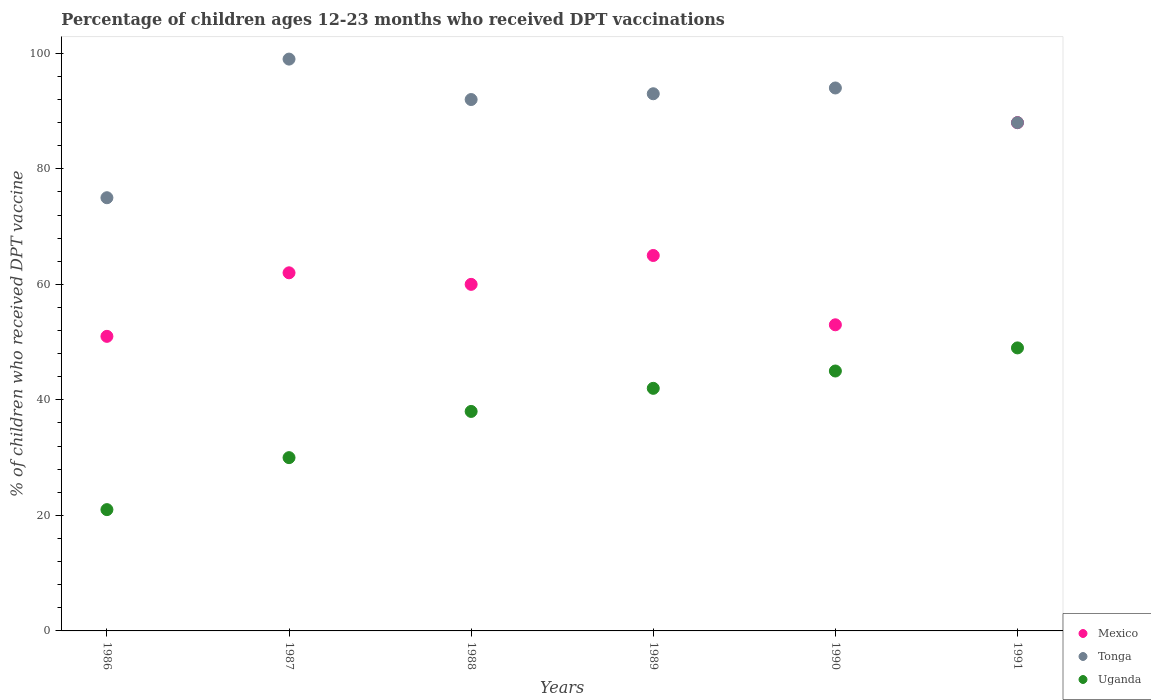Across all years, what is the maximum percentage of children who received DPT vaccination in Tonga?
Ensure brevity in your answer.  99. Across all years, what is the minimum percentage of children who received DPT vaccination in Mexico?
Provide a short and direct response. 51. In which year was the percentage of children who received DPT vaccination in Uganda maximum?
Provide a short and direct response. 1991. In which year was the percentage of children who received DPT vaccination in Uganda minimum?
Provide a short and direct response. 1986. What is the total percentage of children who received DPT vaccination in Mexico in the graph?
Ensure brevity in your answer.  379. What is the difference between the percentage of children who received DPT vaccination in Mexico in 1987 and that in 1989?
Provide a short and direct response. -3. What is the average percentage of children who received DPT vaccination in Mexico per year?
Your answer should be very brief. 63.17. In the year 1991, what is the difference between the percentage of children who received DPT vaccination in Tonga and percentage of children who received DPT vaccination in Uganda?
Ensure brevity in your answer.  39. What is the ratio of the percentage of children who received DPT vaccination in Mexico in 1986 to that in 1987?
Provide a succinct answer. 0.82. Is the difference between the percentage of children who received DPT vaccination in Tonga in 1989 and 1990 greater than the difference between the percentage of children who received DPT vaccination in Uganda in 1989 and 1990?
Offer a terse response. Yes. What is the difference between the highest and the second highest percentage of children who received DPT vaccination in Tonga?
Keep it short and to the point. 5. In how many years, is the percentage of children who received DPT vaccination in Tonga greater than the average percentage of children who received DPT vaccination in Tonga taken over all years?
Your answer should be compact. 4. Is the sum of the percentage of children who received DPT vaccination in Mexico in 1987 and 1991 greater than the maximum percentage of children who received DPT vaccination in Uganda across all years?
Give a very brief answer. Yes. Is it the case that in every year, the sum of the percentage of children who received DPT vaccination in Uganda and percentage of children who received DPT vaccination in Tonga  is greater than the percentage of children who received DPT vaccination in Mexico?
Your answer should be compact. Yes. Does the percentage of children who received DPT vaccination in Tonga monotonically increase over the years?
Ensure brevity in your answer.  No. Is the percentage of children who received DPT vaccination in Mexico strictly less than the percentage of children who received DPT vaccination in Uganda over the years?
Make the answer very short. No. How many dotlines are there?
Provide a succinct answer. 3. How many years are there in the graph?
Your response must be concise. 6. What is the difference between two consecutive major ticks on the Y-axis?
Offer a terse response. 20. Are the values on the major ticks of Y-axis written in scientific E-notation?
Offer a very short reply. No. Does the graph contain any zero values?
Give a very brief answer. No. Does the graph contain grids?
Offer a very short reply. No. Where does the legend appear in the graph?
Keep it short and to the point. Bottom right. How many legend labels are there?
Give a very brief answer. 3. How are the legend labels stacked?
Make the answer very short. Vertical. What is the title of the graph?
Offer a terse response. Percentage of children ages 12-23 months who received DPT vaccinations. Does "Togo" appear as one of the legend labels in the graph?
Your response must be concise. No. What is the label or title of the Y-axis?
Ensure brevity in your answer.  % of children who received DPT vaccine. What is the % of children who received DPT vaccine of Tonga in 1986?
Keep it short and to the point. 75. What is the % of children who received DPT vaccine of Uganda in 1986?
Offer a very short reply. 21. What is the % of children who received DPT vaccine in Mexico in 1988?
Provide a succinct answer. 60. What is the % of children who received DPT vaccine in Tonga in 1988?
Your response must be concise. 92. What is the % of children who received DPT vaccine of Mexico in 1989?
Your answer should be very brief. 65. What is the % of children who received DPT vaccine of Tonga in 1989?
Give a very brief answer. 93. What is the % of children who received DPT vaccine in Uganda in 1989?
Provide a succinct answer. 42. What is the % of children who received DPT vaccine of Tonga in 1990?
Offer a very short reply. 94. What is the % of children who received DPT vaccine of Uganda in 1990?
Your response must be concise. 45. What is the % of children who received DPT vaccine in Mexico in 1991?
Provide a succinct answer. 88. What is the % of children who received DPT vaccine of Tonga in 1991?
Provide a succinct answer. 88. Across all years, what is the maximum % of children who received DPT vaccine in Mexico?
Provide a short and direct response. 88. Across all years, what is the maximum % of children who received DPT vaccine of Tonga?
Keep it short and to the point. 99. Across all years, what is the maximum % of children who received DPT vaccine in Uganda?
Provide a succinct answer. 49. Across all years, what is the minimum % of children who received DPT vaccine of Mexico?
Give a very brief answer. 51. What is the total % of children who received DPT vaccine in Mexico in the graph?
Provide a short and direct response. 379. What is the total % of children who received DPT vaccine of Tonga in the graph?
Your response must be concise. 541. What is the total % of children who received DPT vaccine in Uganda in the graph?
Your answer should be compact. 225. What is the difference between the % of children who received DPT vaccine of Mexico in 1986 and that in 1987?
Ensure brevity in your answer.  -11. What is the difference between the % of children who received DPT vaccine of Uganda in 1986 and that in 1987?
Ensure brevity in your answer.  -9. What is the difference between the % of children who received DPT vaccine in Mexico in 1986 and that in 1989?
Your response must be concise. -14. What is the difference between the % of children who received DPT vaccine in Tonga in 1986 and that in 1989?
Offer a very short reply. -18. What is the difference between the % of children who received DPT vaccine in Mexico in 1986 and that in 1991?
Offer a terse response. -37. What is the difference between the % of children who received DPT vaccine in Mexico in 1987 and that in 1988?
Your answer should be compact. 2. What is the difference between the % of children who received DPT vaccine in Mexico in 1987 and that in 1989?
Keep it short and to the point. -3. What is the difference between the % of children who received DPT vaccine of Tonga in 1987 and that in 1989?
Keep it short and to the point. 6. What is the difference between the % of children who received DPT vaccine of Tonga in 1987 and that in 1990?
Keep it short and to the point. 5. What is the difference between the % of children who received DPT vaccine in Mexico in 1988 and that in 1990?
Provide a succinct answer. 7. What is the difference between the % of children who received DPT vaccine in Uganda in 1988 and that in 1990?
Offer a terse response. -7. What is the difference between the % of children who received DPT vaccine of Mexico in 1988 and that in 1991?
Offer a very short reply. -28. What is the difference between the % of children who received DPT vaccine in Tonga in 1988 and that in 1991?
Your response must be concise. 4. What is the difference between the % of children who received DPT vaccine in Uganda in 1988 and that in 1991?
Offer a terse response. -11. What is the difference between the % of children who received DPT vaccine in Mexico in 1989 and that in 1990?
Your answer should be compact. 12. What is the difference between the % of children who received DPT vaccine in Tonga in 1989 and that in 1990?
Your answer should be compact. -1. What is the difference between the % of children who received DPT vaccine of Uganda in 1989 and that in 1991?
Make the answer very short. -7. What is the difference between the % of children who received DPT vaccine in Mexico in 1990 and that in 1991?
Offer a terse response. -35. What is the difference between the % of children who received DPT vaccine of Uganda in 1990 and that in 1991?
Your answer should be compact. -4. What is the difference between the % of children who received DPT vaccine of Mexico in 1986 and the % of children who received DPT vaccine of Tonga in 1987?
Provide a short and direct response. -48. What is the difference between the % of children who received DPT vaccine of Mexico in 1986 and the % of children who received DPT vaccine of Tonga in 1988?
Provide a short and direct response. -41. What is the difference between the % of children who received DPT vaccine in Mexico in 1986 and the % of children who received DPT vaccine in Tonga in 1989?
Offer a very short reply. -42. What is the difference between the % of children who received DPT vaccine of Mexico in 1986 and the % of children who received DPT vaccine of Uganda in 1989?
Your answer should be very brief. 9. What is the difference between the % of children who received DPT vaccine in Mexico in 1986 and the % of children who received DPT vaccine in Tonga in 1990?
Provide a short and direct response. -43. What is the difference between the % of children who received DPT vaccine in Mexico in 1986 and the % of children who received DPT vaccine in Uganda in 1990?
Offer a terse response. 6. What is the difference between the % of children who received DPT vaccine of Tonga in 1986 and the % of children who received DPT vaccine of Uganda in 1990?
Ensure brevity in your answer.  30. What is the difference between the % of children who received DPT vaccine of Mexico in 1986 and the % of children who received DPT vaccine of Tonga in 1991?
Offer a very short reply. -37. What is the difference between the % of children who received DPT vaccine in Mexico in 1986 and the % of children who received DPT vaccine in Uganda in 1991?
Give a very brief answer. 2. What is the difference between the % of children who received DPT vaccine in Tonga in 1986 and the % of children who received DPT vaccine in Uganda in 1991?
Provide a short and direct response. 26. What is the difference between the % of children who received DPT vaccine of Mexico in 1987 and the % of children who received DPT vaccine of Tonga in 1989?
Ensure brevity in your answer.  -31. What is the difference between the % of children who received DPT vaccine in Mexico in 1987 and the % of children who received DPT vaccine in Uganda in 1989?
Keep it short and to the point. 20. What is the difference between the % of children who received DPT vaccine of Tonga in 1987 and the % of children who received DPT vaccine of Uganda in 1989?
Provide a succinct answer. 57. What is the difference between the % of children who received DPT vaccine of Mexico in 1987 and the % of children who received DPT vaccine of Tonga in 1990?
Keep it short and to the point. -32. What is the difference between the % of children who received DPT vaccine of Mexico in 1987 and the % of children who received DPT vaccine of Uganda in 1990?
Your response must be concise. 17. What is the difference between the % of children who received DPT vaccine of Tonga in 1987 and the % of children who received DPT vaccine of Uganda in 1990?
Provide a short and direct response. 54. What is the difference between the % of children who received DPT vaccine in Tonga in 1987 and the % of children who received DPT vaccine in Uganda in 1991?
Make the answer very short. 50. What is the difference between the % of children who received DPT vaccine of Mexico in 1988 and the % of children who received DPT vaccine of Tonga in 1989?
Offer a terse response. -33. What is the difference between the % of children who received DPT vaccine in Mexico in 1988 and the % of children who received DPT vaccine in Uganda in 1989?
Ensure brevity in your answer.  18. What is the difference between the % of children who received DPT vaccine in Tonga in 1988 and the % of children who received DPT vaccine in Uganda in 1989?
Your answer should be very brief. 50. What is the difference between the % of children who received DPT vaccine in Mexico in 1988 and the % of children who received DPT vaccine in Tonga in 1990?
Provide a short and direct response. -34. What is the difference between the % of children who received DPT vaccine of Tonga in 1988 and the % of children who received DPT vaccine of Uganda in 1990?
Offer a terse response. 47. What is the difference between the % of children who received DPT vaccine of Mexico in 1988 and the % of children who received DPT vaccine of Tonga in 1991?
Give a very brief answer. -28. What is the difference between the % of children who received DPT vaccine in Tonga in 1988 and the % of children who received DPT vaccine in Uganda in 1991?
Your response must be concise. 43. What is the difference between the % of children who received DPT vaccine of Mexico in 1989 and the % of children who received DPT vaccine of Tonga in 1990?
Offer a terse response. -29. What is the difference between the % of children who received DPT vaccine in Tonga in 1989 and the % of children who received DPT vaccine in Uganda in 1990?
Offer a very short reply. 48. What is the difference between the % of children who received DPT vaccine of Mexico in 1989 and the % of children who received DPT vaccine of Uganda in 1991?
Offer a very short reply. 16. What is the difference between the % of children who received DPT vaccine in Tonga in 1989 and the % of children who received DPT vaccine in Uganda in 1991?
Provide a succinct answer. 44. What is the difference between the % of children who received DPT vaccine in Mexico in 1990 and the % of children who received DPT vaccine in Tonga in 1991?
Provide a succinct answer. -35. What is the difference between the % of children who received DPT vaccine in Tonga in 1990 and the % of children who received DPT vaccine in Uganda in 1991?
Your response must be concise. 45. What is the average % of children who received DPT vaccine of Mexico per year?
Provide a succinct answer. 63.17. What is the average % of children who received DPT vaccine of Tonga per year?
Your answer should be very brief. 90.17. What is the average % of children who received DPT vaccine in Uganda per year?
Your answer should be compact. 37.5. In the year 1986, what is the difference between the % of children who received DPT vaccine in Mexico and % of children who received DPT vaccine in Uganda?
Your answer should be compact. 30. In the year 1986, what is the difference between the % of children who received DPT vaccine of Tonga and % of children who received DPT vaccine of Uganda?
Give a very brief answer. 54. In the year 1987, what is the difference between the % of children who received DPT vaccine in Mexico and % of children who received DPT vaccine in Tonga?
Your answer should be compact. -37. In the year 1988, what is the difference between the % of children who received DPT vaccine of Mexico and % of children who received DPT vaccine of Tonga?
Provide a short and direct response. -32. In the year 1988, what is the difference between the % of children who received DPT vaccine in Tonga and % of children who received DPT vaccine in Uganda?
Your answer should be compact. 54. In the year 1989, what is the difference between the % of children who received DPT vaccine in Tonga and % of children who received DPT vaccine in Uganda?
Your answer should be compact. 51. In the year 1990, what is the difference between the % of children who received DPT vaccine in Mexico and % of children who received DPT vaccine in Tonga?
Make the answer very short. -41. In the year 1991, what is the difference between the % of children who received DPT vaccine of Mexico and % of children who received DPT vaccine of Uganda?
Offer a terse response. 39. In the year 1991, what is the difference between the % of children who received DPT vaccine in Tonga and % of children who received DPT vaccine in Uganda?
Provide a succinct answer. 39. What is the ratio of the % of children who received DPT vaccine of Mexico in 1986 to that in 1987?
Offer a very short reply. 0.82. What is the ratio of the % of children who received DPT vaccine of Tonga in 1986 to that in 1987?
Your response must be concise. 0.76. What is the ratio of the % of children who received DPT vaccine of Uganda in 1986 to that in 1987?
Give a very brief answer. 0.7. What is the ratio of the % of children who received DPT vaccine of Mexico in 1986 to that in 1988?
Your answer should be very brief. 0.85. What is the ratio of the % of children who received DPT vaccine in Tonga in 1986 to that in 1988?
Keep it short and to the point. 0.82. What is the ratio of the % of children who received DPT vaccine in Uganda in 1986 to that in 1988?
Your response must be concise. 0.55. What is the ratio of the % of children who received DPT vaccine of Mexico in 1986 to that in 1989?
Ensure brevity in your answer.  0.78. What is the ratio of the % of children who received DPT vaccine in Tonga in 1986 to that in 1989?
Offer a very short reply. 0.81. What is the ratio of the % of children who received DPT vaccine in Uganda in 1986 to that in 1989?
Make the answer very short. 0.5. What is the ratio of the % of children who received DPT vaccine in Mexico in 1986 to that in 1990?
Your answer should be very brief. 0.96. What is the ratio of the % of children who received DPT vaccine in Tonga in 1986 to that in 1990?
Provide a short and direct response. 0.8. What is the ratio of the % of children who received DPT vaccine of Uganda in 1986 to that in 1990?
Offer a terse response. 0.47. What is the ratio of the % of children who received DPT vaccine in Mexico in 1986 to that in 1991?
Make the answer very short. 0.58. What is the ratio of the % of children who received DPT vaccine in Tonga in 1986 to that in 1991?
Your answer should be compact. 0.85. What is the ratio of the % of children who received DPT vaccine of Uganda in 1986 to that in 1991?
Provide a succinct answer. 0.43. What is the ratio of the % of children who received DPT vaccine in Tonga in 1987 to that in 1988?
Provide a short and direct response. 1.08. What is the ratio of the % of children who received DPT vaccine in Uganda in 1987 to that in 1988?
Your answer should be compact. 0.79. What is the ratio of the % of children who received DPT vaccine of Mexico in 1987 to that in 1989?
Ensure brevity in your answer.  0.95. What is the ratio of the % of children who received DPT vaccine of Tonga in 1987 to that in 1989?
Provide a succinct answer. 1.06. What is the ratio of the % of children who received DPT vaccine in Uganda in 1987 to that in 1989?
Your answer should be compact. 0.71. What is the ratio of the % of children who received DPT vaccine of Mexico in 1987 to that in 1990?
Provide a short and direct response. 1.17. What is the ratio of the % of children who received DPT vaccine in Tonga in 1987 to that in 1990?
Your answer should be compact. 1.05. What is the ratio of the % of children who received DPT vaccine of Uganda in 1987 to that in 1990?
Ensure brevity in your answer.  0.67. What is the ratio of the % of children who received DPT vaccine of Mexico in 1987 to that in 1991?
Provide a succinct answer. 0.7. What is the ratio of the % of children who received DPT vaccine of Uganda in 1987 to that in 1991?
Provide a succinct answer. 0.61. What is the ratio of the % of children who received DPT vaccine in Mexico in 1988 to that in 1989?
Keep it short and to the point. 0.92. What is the ratio of the % of children who received DPT vaccine in Tonga in 1988 to that in 1989?
Offer a terse response. 0.99. What is the ratio of the % of children who received DPT vaccine of Uganda in 1988 to that in 1989?
Ensure brevity in your answer.  0.9. What is the ratio of the % of children who received DPT vaccine in Mexico in 1988 to that in 1990?
Keep it short and to the point. 1.13. What is the ratio of the % of children who received DPT vaccine in Tonga in 1988 to that in 1990?
Your response must be concise. 0.98. What is the ratio of the % of children who received DPT vaccine of Uganda in 1988 to that in 1990?
Ensure brevity in your answer.  0.84. What is the ratio of the % of children who received DPT vaccine of Mexico in 1988 to that in 1991?
Your answer should be very brief. 0.68. What is the ratio of the % of children who received DPT vaccine in Tonga in 1988 to that in 1991?
Provide a succinct answer. 1.05. What is the ratio of the % of children who received DPT vaccine in Uganda in 1988 to that in 1991?
Your response must be concise. 0.78. What is the ratio of the % of children who received DPT vaccine of Mexico in 1989 to that in 1990?
Your answer should be compact. 1.23. What is the ratio of the % of children who received DPT vaccine of Uganda in 1989 to that in 1990?
Your response must be concise. 0.93. What is the ratio of the % of children who received DPT vaccine of Mexico in 1989 to that in 1991?
Offer a terse response. 0.74. What is the ratio of the % of children who received DPT vaccine in Tonga in 1989 to that in 1991?
Ensure brevity in your answer.  1.06. What is the ratio of the % of children who received DPT vaccine of Mexico in 1990 to that in 1991?
Ensure brevity in your answer.  0.6. What is the ratio of the % of children who received DPT vaccine in Tonga in 1990 to that in 1991?
Give a very brief answer. 1.07. What is the ratio of the % of children who received DPT vaccine of Uganda in 1990 to that in 1991?
Your answer should be compact. 0.92. What is the difference between the highest and the second highest % of children who received DPT vaccine of Tonga?
Provide a short and direct response. 5. What is the difference between the highest and the lowest % of children who received DPT vaccine of Tonga?
Make the answer very short. 24. 